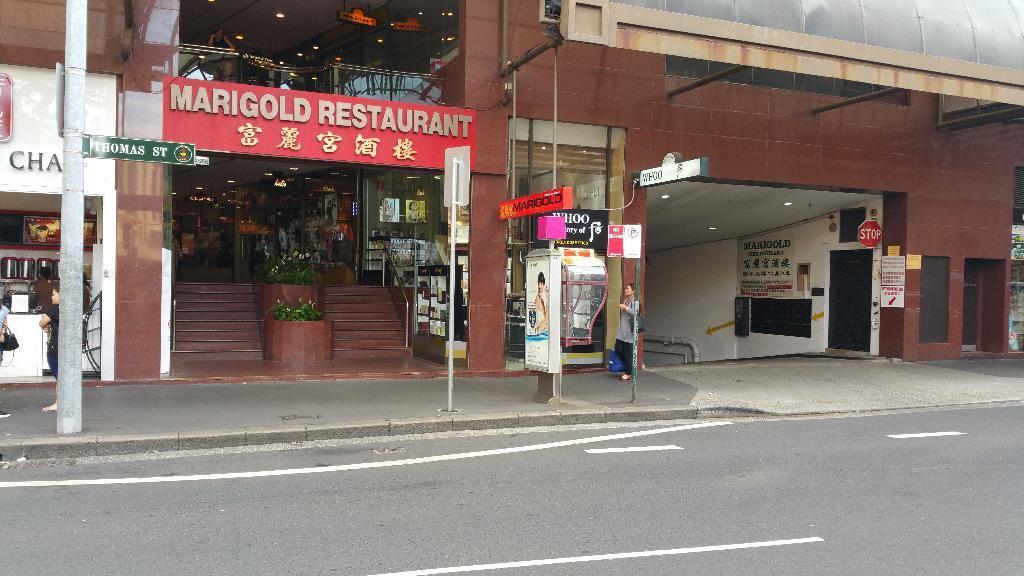How would you summarize this image in a sentence or two? This picture is clicked outside the city. At the bottom of the picture, we see the road. Beside that, we see the poles and the boards in white, red and green color with some text written on it. Beside that, the woman in the green dress is walking on the footpath. On the left side, we see two people are standing. In front of them, we see a stall. Beside that, we see a buildings and the staircase. We see the flower pots. In the middle of the picture, we see the red color board with some text written on it. On the right side, we see a building in brown color and we see a stop board and posters are pasted on the white wall. 